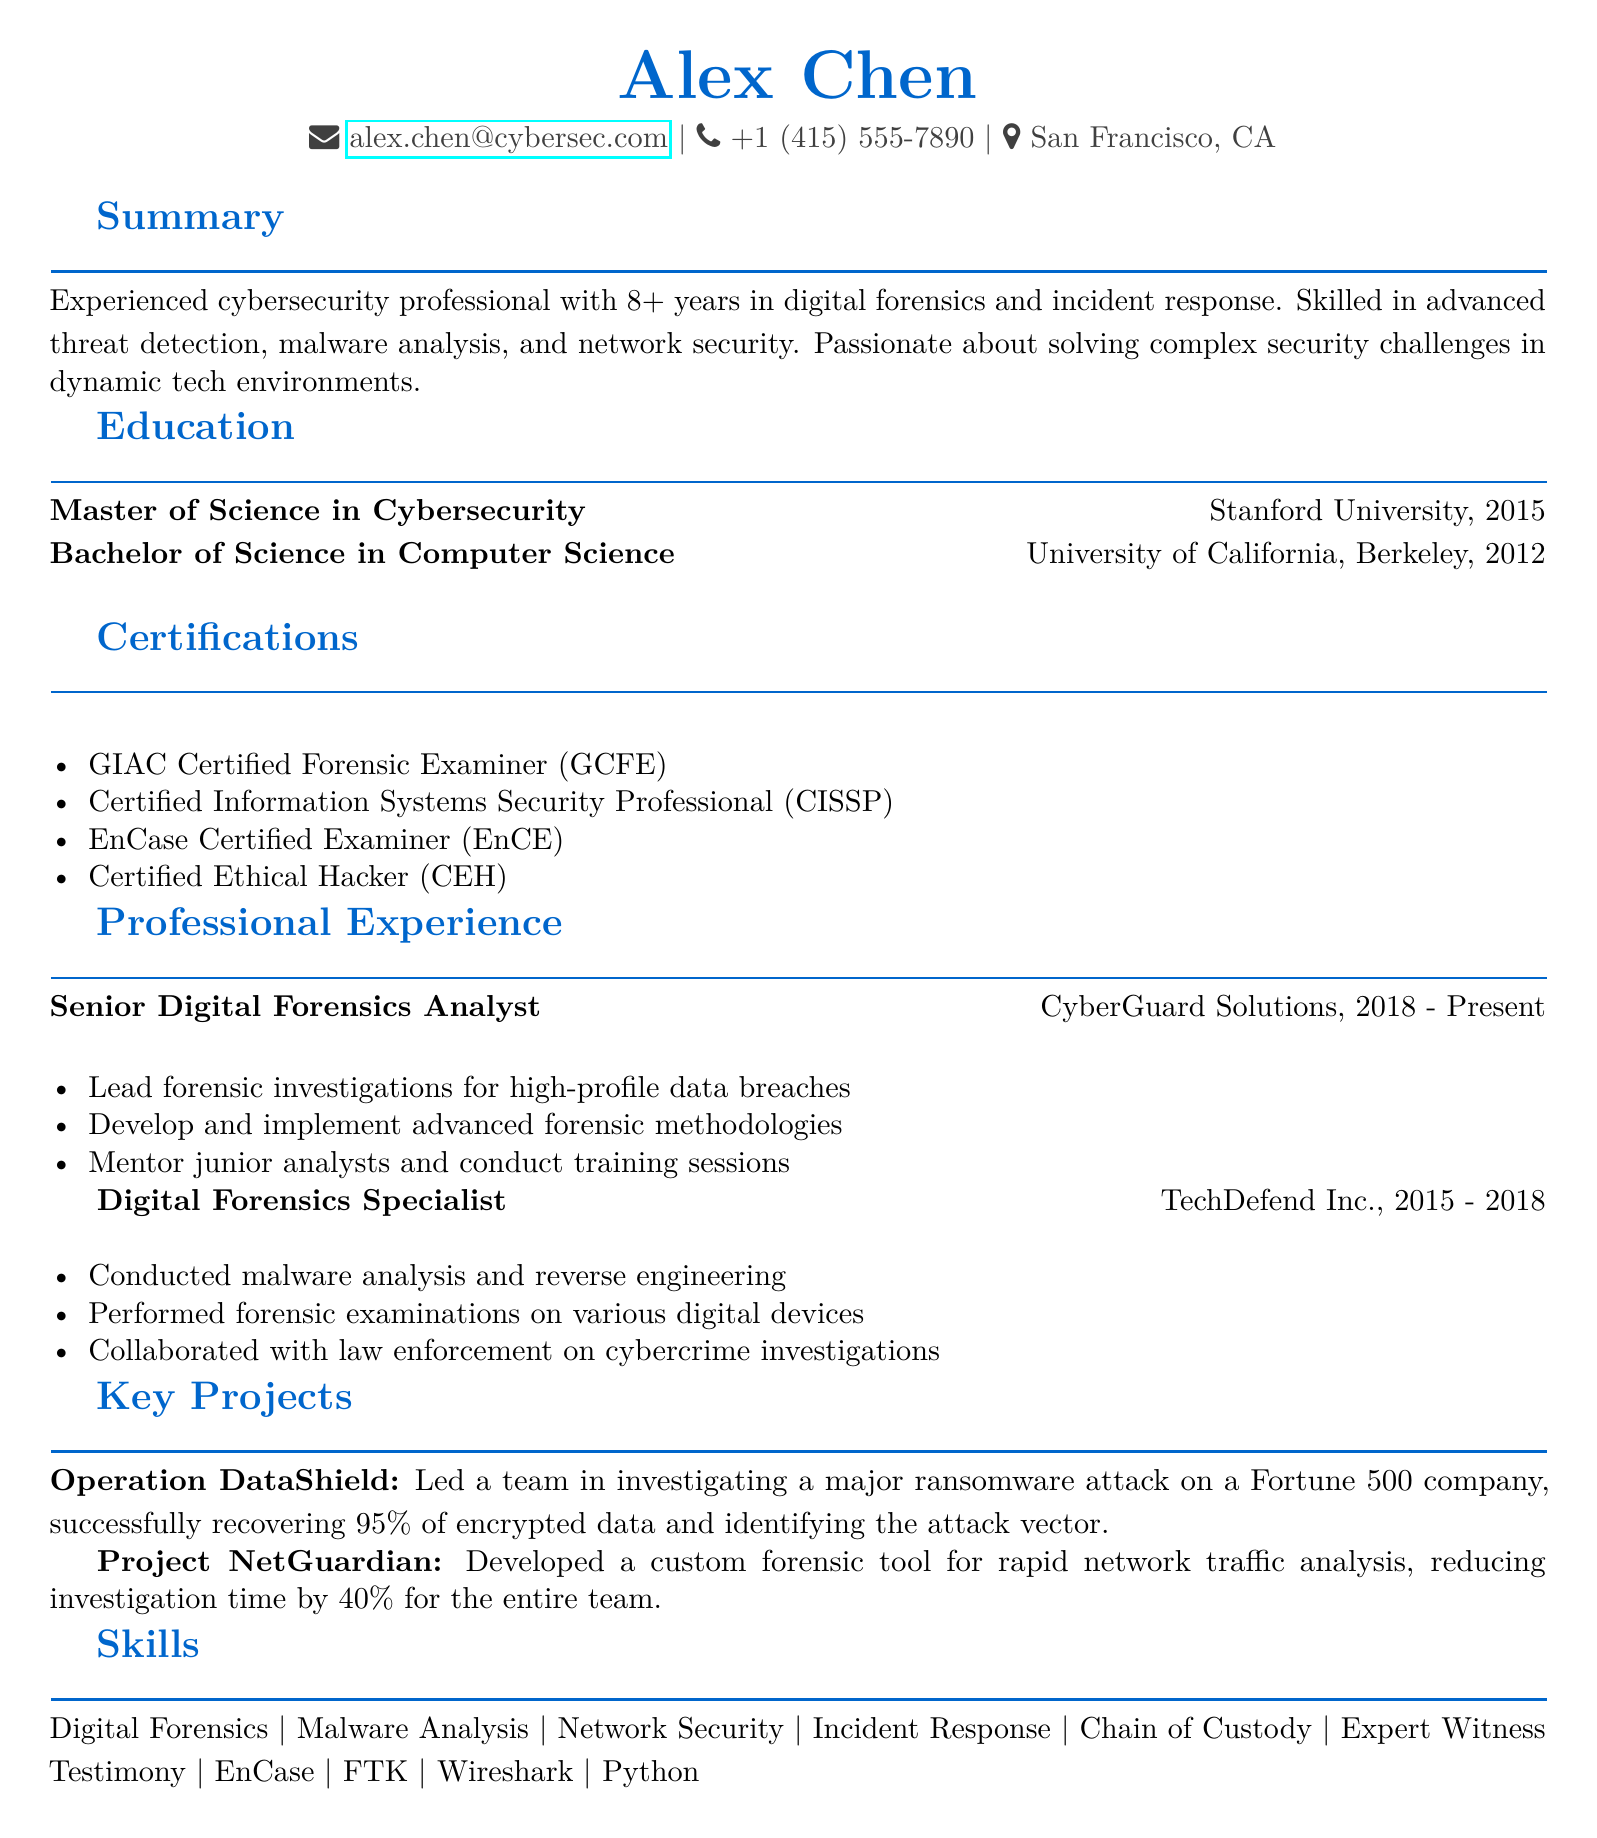What is the name of the individual? The name is prominently displayed at the top of the document.
Answer: Alex Chen What is Alex Chen's email address? The email address is listed under personal information.
Answer: alex.chen@cybersec.com Which company does Alex work for currently? This information is found in the experience section listing job titles and companies.
Answer: CyberGuard Solutions In what year did Alex complete his Bachelor's degree? The year of graduation is given in the education section.
Answer: 2012 How many years of experience does Alex have in cybersecurity? The summary section states the years of expertise.
Answer: 8+ What is one of the key projects Alex led? The key projects section provides specific names of projects.
Answer: Operation DataShield What certification specializes in digital forensics? The certifications section lists various credentials, including one focused on forensics.
Answer: GIAC Certified Forensic Examiner (GCFE) How much did investigation time reduce by Project NetGuardian? The description of the project provides this metric.
Answer: 40% What did Alex develop for rapid network traffic analysis? This information is detailed in the Project NetGuardian description.
Answer: A custom forensic tool What is one of Alex's skills listed? The skills section enumerates relevant proficiencies.
Answer: Digital Forensics 